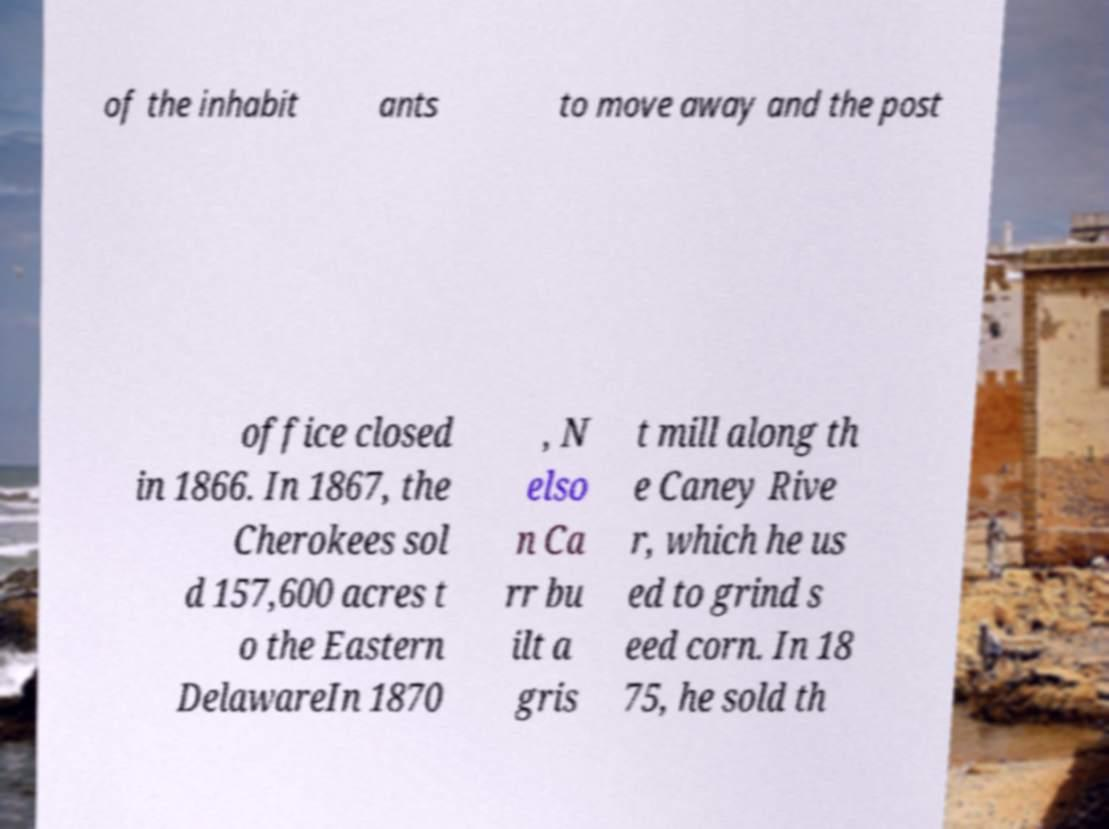For documentation purposes, I need the text within this image transcribed. Could you provide that? of the inhabit ants to move away and the post office closed in 1866. In 1867, the Cherokees sol d 157,600 acres t o the Eastern DelawareIn 1870 , N elso n Ca rr bu ilt a gris t mill along th e Caney Rive r, which he us ed to grind s eed corn. In 18 75, he sold th 